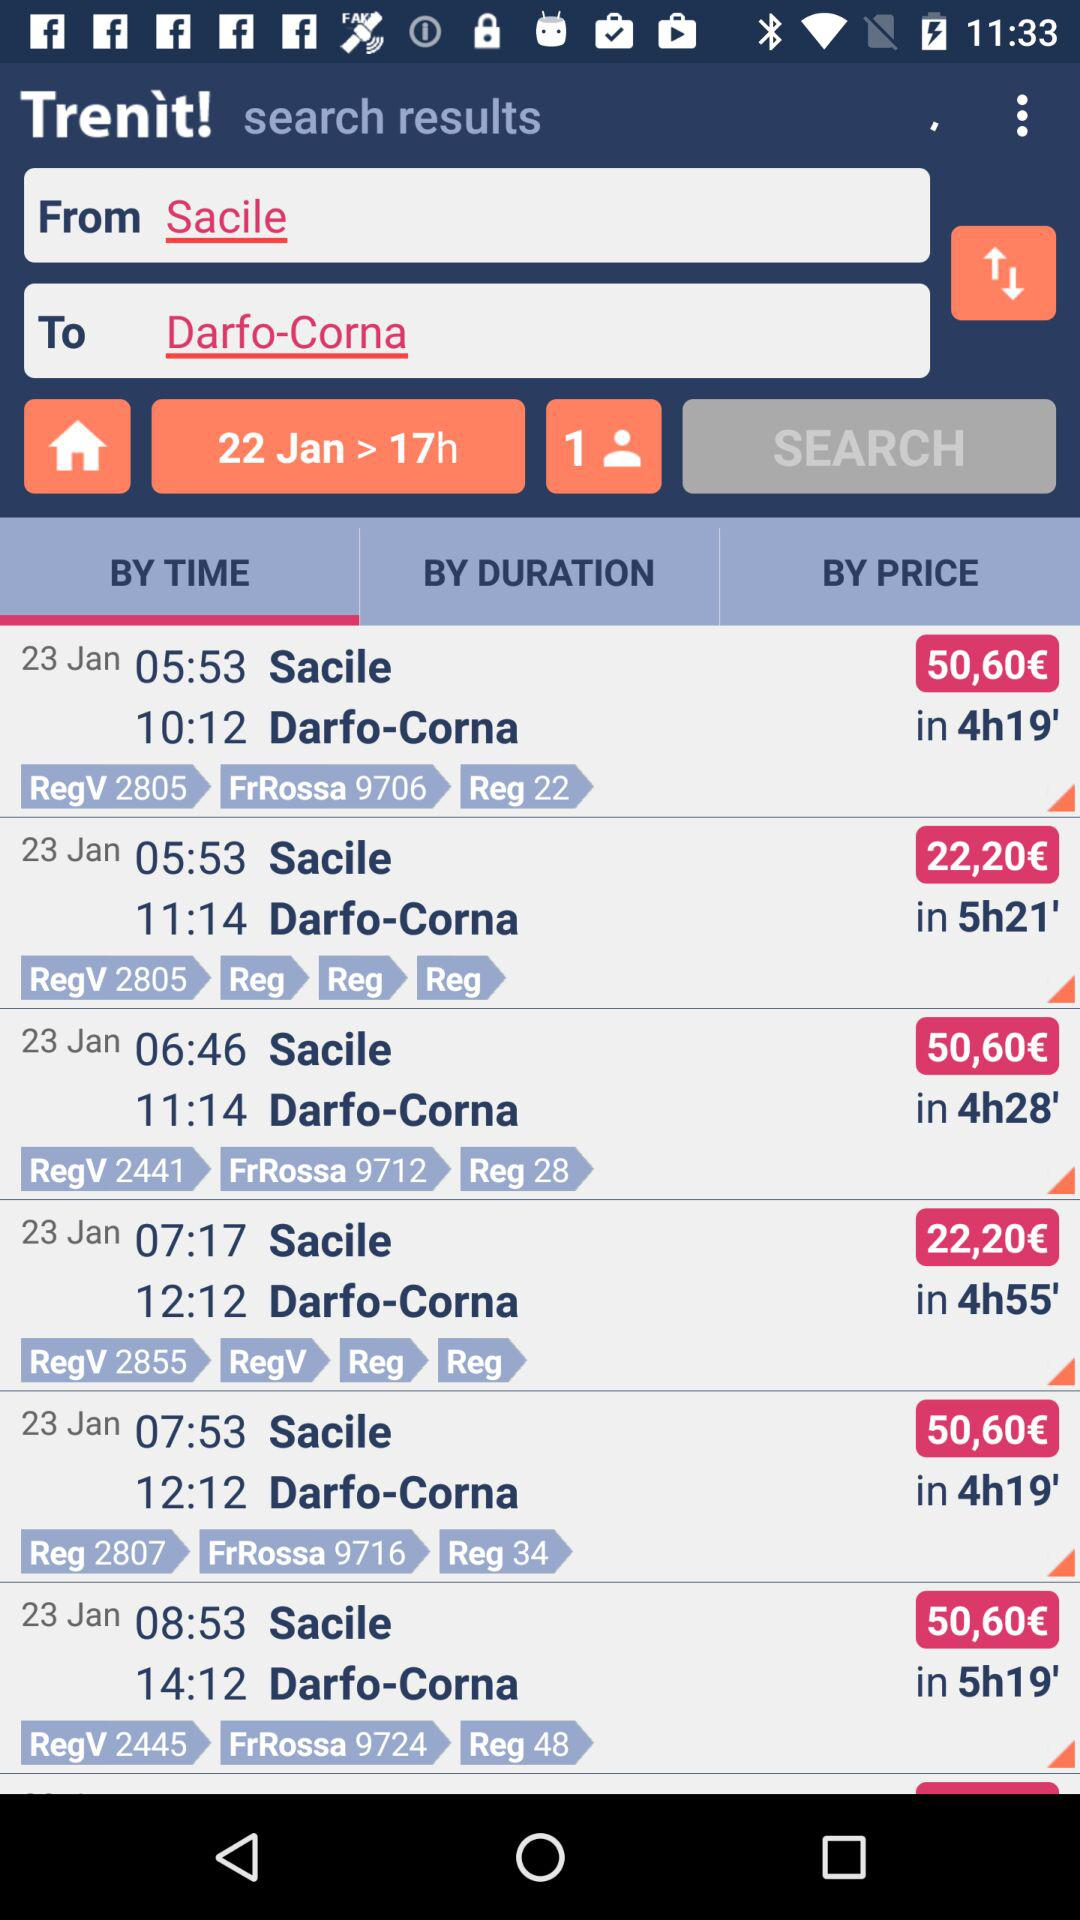What is the time duration search for 22 jan in "SEARCH" box? The time duration is 17 hours. 